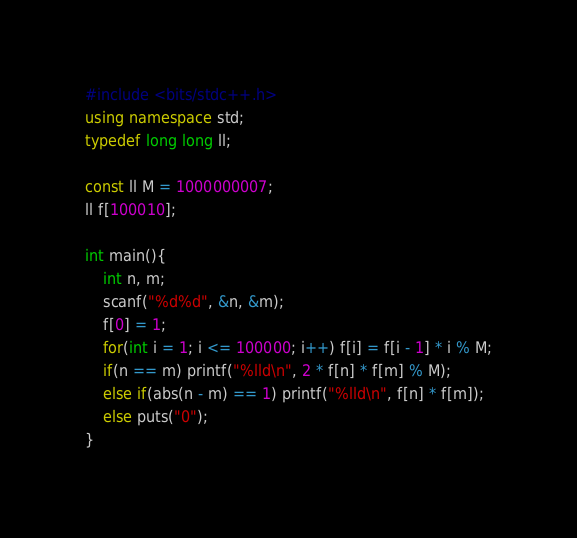Convert code to text. <code><loc_0><loc_0><loc_500><loc_500><_C++_>#include <bits/stdc++.h>
using namespace std;
typedef long long ll;

const ll M = 1000000007;
ll f[100010];

int main(){
	int n, m;
	scanf("%d%d", &n, &m);
	f[0] = 1;
	for(int i = 1; i <= 100000; i++) f[i] = f[i - 1] * i % M;
	if(n == m) printf("%lld\n", 2 * f[n] * f[m] % M);
	else if(abs(n - m) == 1) printf("%lld\n", f[n] * f[m]);
	else puts("0");
}</code> 